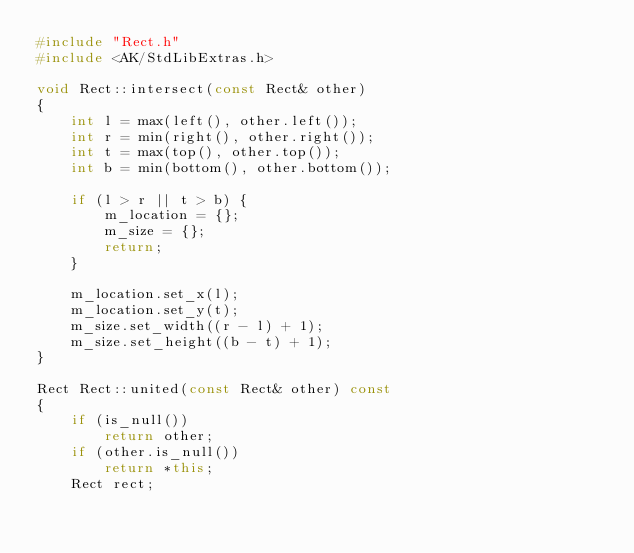Convert code to text. <code><loc_0><loc_0><loc_500><loc_500><_C++_>#include "Rect.h"
#include <AK/StdLibExtras.h>

void Rect::intersect(const Rect& other)
{
    int l = max(left(), other.left());
    int r = min(right(), other.right());
    int t = max(top(), other.top());
    int b = min(bottom(), other.bottom());

    if (l > r || t > b) {
        m_location = {};
        m_size = {};
        return;
    }

    m_location.set_x(l);
    m_location.set_y(t);
    m_size.set_width((r - l) + 1);
    m_size.set_height((b - t) + 1);
}

Rect Rect::united(const Rect& other) const
{
    if (is_null())
        return other;
    if (other.is_null())
        return *this;
    Rect rect;</code> 